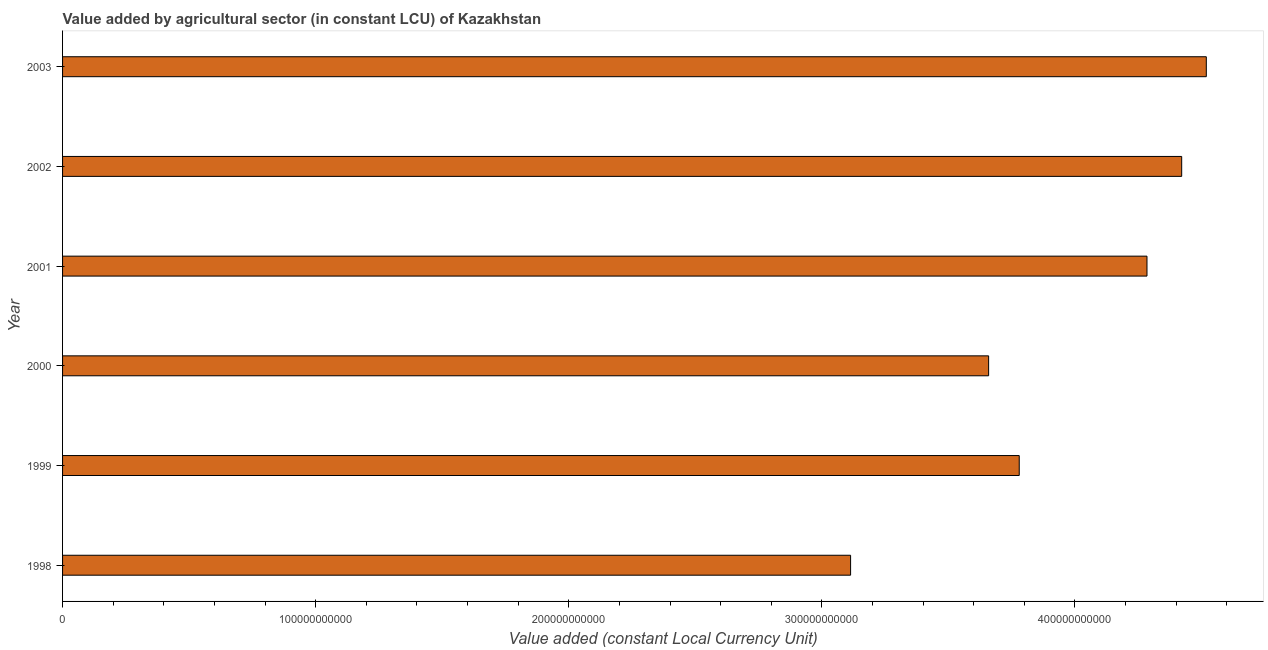Does the graph contain any zero values?
Your answer should be compact. No. Does the graph contain grids?
Offer a very short reply. No. What is the title of the graph?
Provide a short and direct response. Value added by agricultural sector (in constant LCU) of Kazakhstan. What is the label or title of the X-axis?
Provide a short and direct response. Value added (constant Local Currency Unit). What is the label or title of the Y-axis?
Keep it short and to the point. Year. What is the value added by agriculture sector in 2000?
Your answer should be very brief. 3.66e+11. Across all years, what is the maximum value added by agriculture sector?
Offer a terse response. 4.52e+11. Across all years, what is the minimum value added by agriculture sector?
Your answer should be very brief. 3.11e+11. What is the sum of the value added by agriculture sector?
Your response must be concise. 2.38e+12. What is the difference between the value added by agriculture sector in 1999 and 2000?
Make the answer very short. 1.21e+1. What is the average value added by agriculture sector per year?
Offer a terse response. 3.96e+11. What is the median value added by agriculture sector?
Make the answer very short. 4.03e+11. In how many years, is the value added by agriculture sector greater than 140000000000 LCU?
Provide a short and direct response. 6. Do a majority of the years between 1999 and 2003 (inclusive) have value added by agriculture sector greater than 140000000000 LCU?
Ensure brevity in your answer.  Yes. What is the ratio of the value added by agriculture sector in 1998 to that in 2000?
Your answer should be compact. 0.85. Is the value added by agriculture sector in 1998 less than that in 2002?
Your response must be concise. Yes. What is the difference between the highest and the second highest value added by agriculture sector?
Keep it short and to the point. 9.73e+09. What is the difference between the highest and the lowest value added by agriculture sector?
Provide a short and direct response. 1.41e+11. In how many years, is the value added by agriculture sector greater than the average value added by agriculture sector taken over all years?
Make the answer very short. 3. How many bars are there?
Make the answer very short. 6. What is the difference between two consecutive major ticks on the X-axis?
Provide a short and direct response. 1.00e+11. Are the values on the major ticks of X-axis written in scientific E-notation?
Make the answer very short. No. What is the Value added (constant Local Currency Unit) in 1998?
Provide a succinct answer. 3.11e+11. What is the Value added (constant Local Currency Unit) in 1999?
Ensure brevity in your answer.  3.78e+11. What is the Value added (constant Local Currency Unit) of 2000?
Offer a terse response. 3.66e+11. What is the Value added (constant Local Currency Unit) of 2001?
Offer a terse response. 4.28e+11. What is the Value added (constant Local Currency Unit) of 2002?
Make the answer very short. 4.42e+11. What is the Value added (constant Local Currency Unit) of 2003?
Keep it short and to the point. 4.52e+11. What is the difference between the Value added (constant Local Currency Unit) in 1998 and 1999?
Keep it short and to the point. -6.66e+1. What is the difference between the Value added (constant Local Currency Unit) in 1998 and 2000?
Keep it short and to the point. -5.45e+1. What is the difference between the Value added (constant Local Currency Unit) in 1998 and 2001?
Your answer should be very brief. -1.17e+11. What is the difference between the Value added (constant Local Currency Unit) in 1998 and 2002?
Your response must be concise. -1.31e+11. What is the difference between the Value added (constant Local Currency Unit) in 1998 and 2003?
Provide a short and direct response. -1.41e+11. What is the difference between the Value added (constant Local Currency Unit) in 1999 and 2000?
Make the answer very short. 1.21e+1. What is the difference between the Value added (constant Local Currency Unit) in 1999 and 2001?
Your answer should be very brief. -5.05e+1. What is the difference between the Value added (constant Local Currency Unit) in 1999 and 2002?
Provide a short and direct response. -6.42e+1. What is the difference between the Value added (constant Local Currency Unit) in 1999 and 2003?
Your response must be concise. -7.39e+1. What is the difference between the Value added (constant Local Currency Unit) in 2000 and 2001?
Offer a very short reply. -6.26e+1. What is the difference between the Value added (constant Local Currency Unit) in 2000 and 2002?
Ensure brevity in your answer.  -7.63e+1. What is the difference between the Value added (constant Local Currency Unit) in 2000 and 2003?
Make the answer very short. -8.60e+1. What is the difference between the Value added (constant Local Currency Unit) in 2001 and 2002?
Make the answer very short. -1.37e+1. What is the difference between the Value added (constant Local Currency Unit) in 2001 and 2003?
Ensure brevity in your answer.  -2.34e+1. What is the difference between the Value added (constant Local Currency Unit) in 2002 and 2003?
Offer a terse response. -9.73e+09. What is the ratio of the Value added (constant Local Currency Unit) in 1998 to that in 1999?
Offer a very short reply. 0.82. What is the ratio of the Value added (constant Local Currency Unit) in 1998 to that in 2000?
Your answer should be compact. 0.85. What is the ratio of the Value added (constant Local Currency Unit) in 1998 to that in 2001?
Provide a short and direct response. 0.73. What is the ratio of the Value added (constant Local Currency Unit) in 1998 to that in 2002?
Keep it short and to the point. 0.7. What is the ratio of the Value added (constant Local Currency Unit) in 1998 to that in 2003?
Provide a short and direct response. 0.69. What is the ratio of the Value added (constant Local Currency Unit) in 1999 to that in 2000?
Your response must be concise. 1.03. What is the ratio of the Value added (constant Local Currency Unit) in 1999 to that in 2001?
Keep it short and to the point. 0.88. What is the ratio of the Value added (constant Local Currency Unit) in 1999 to that in 2002?
Your answer should be compact. 0.85. What is the ratio of the Value added (constant Local Currency Unit) in 1999 to that in 2003?
Ensure brevity in your answer.  0.84. What is the ratio of the Value added (constant Local Currency Unit) in 2000 to that in 2001?
Your answer should be compact. 0.85. What is the ratio of the Value added (constant Local Currency Unit) in 2000 to that in 2002?
Provide a short and direct response. 0.83. What is the ratio of the Value added (constant Local Currency Unit) in 2000 to that in 2003?
Make the answer very short. 0.81. What is the ratio of the Value added (constant Local Currency Unit) in 2001 to that in 2003?
Your answer should be very brief. 0.95. 